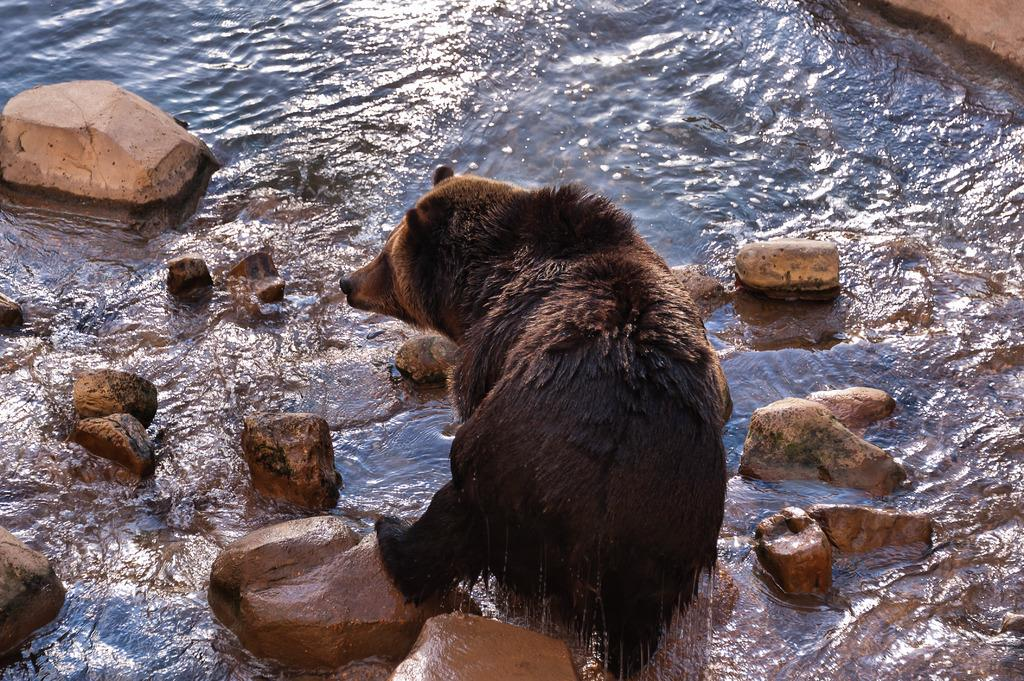What is present in the image that is not solid? There is water visible in the image. What can be seen on the ground in the image? There are stones on the ground in the image. What type of animal is in the water in the image? There is an animal in the water in the image. What type of jewel can be seen on the animal's head in the image? There is no jewel present on the animal's head in the image. How does the yak push the stones in the image? There is no yak present in the image, so it cannot push the stones. 